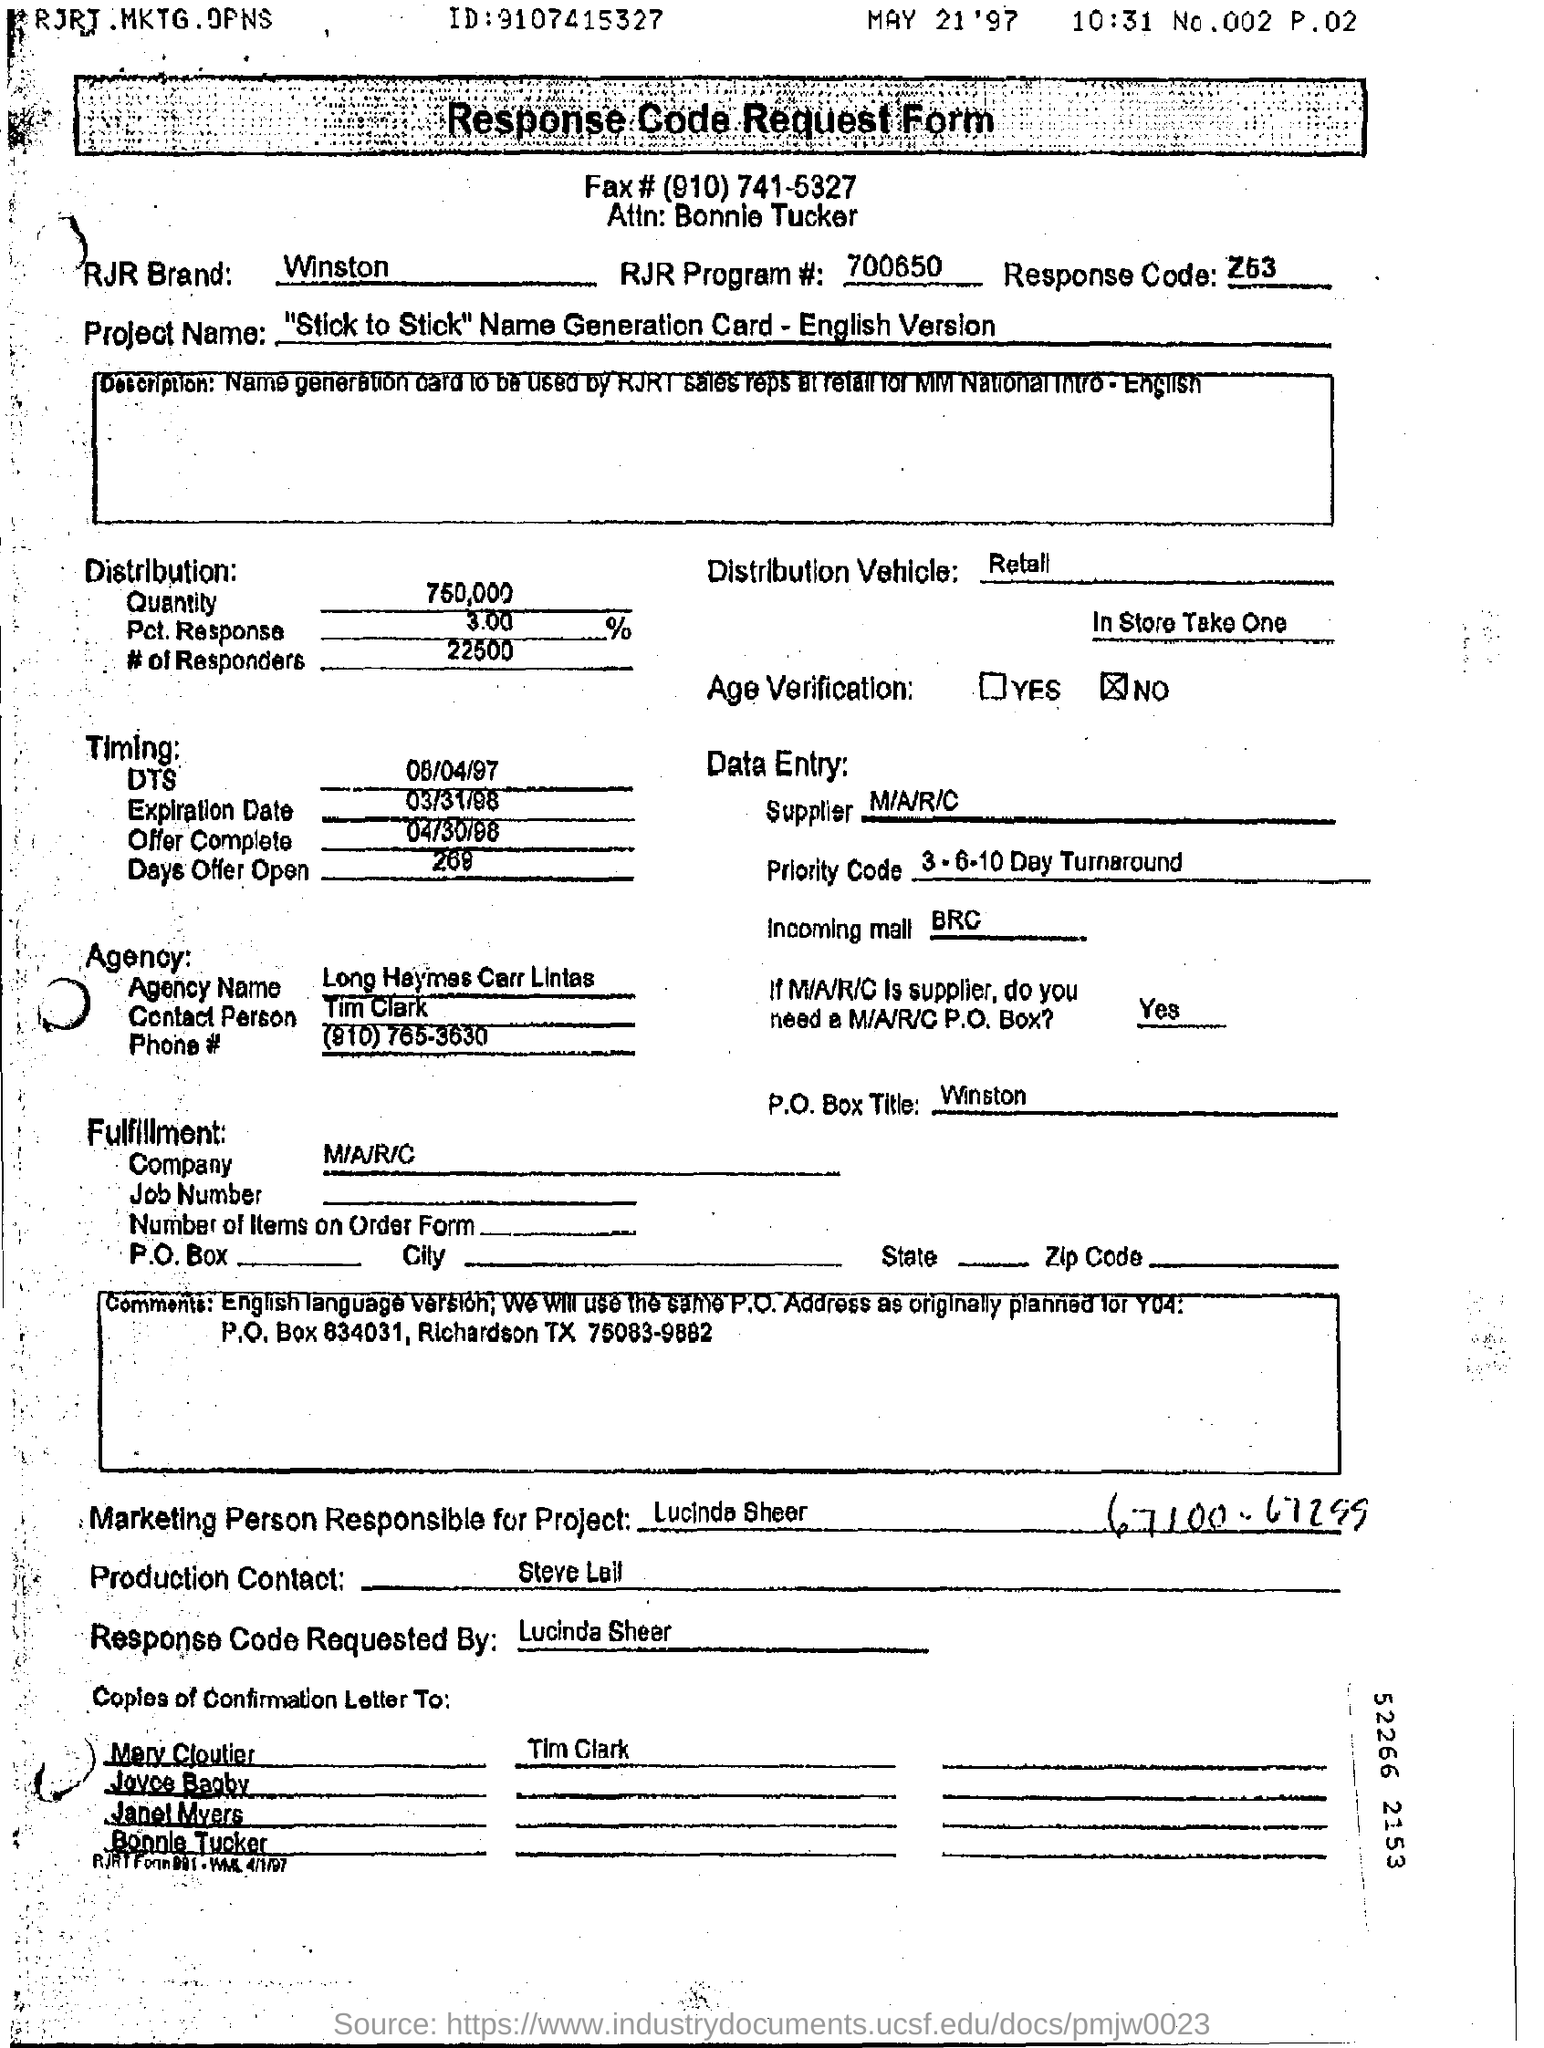What is the Project Name?
Offer a terse response. "Stick to Stick” Name Generation Card - English Version. Who is the Marketing Person Responsible for Project?
Keep it short and to the point. Lucinda Sheer. By whom is the Response Code Requested?
Make the answer very short. Lucinda Sheer. 